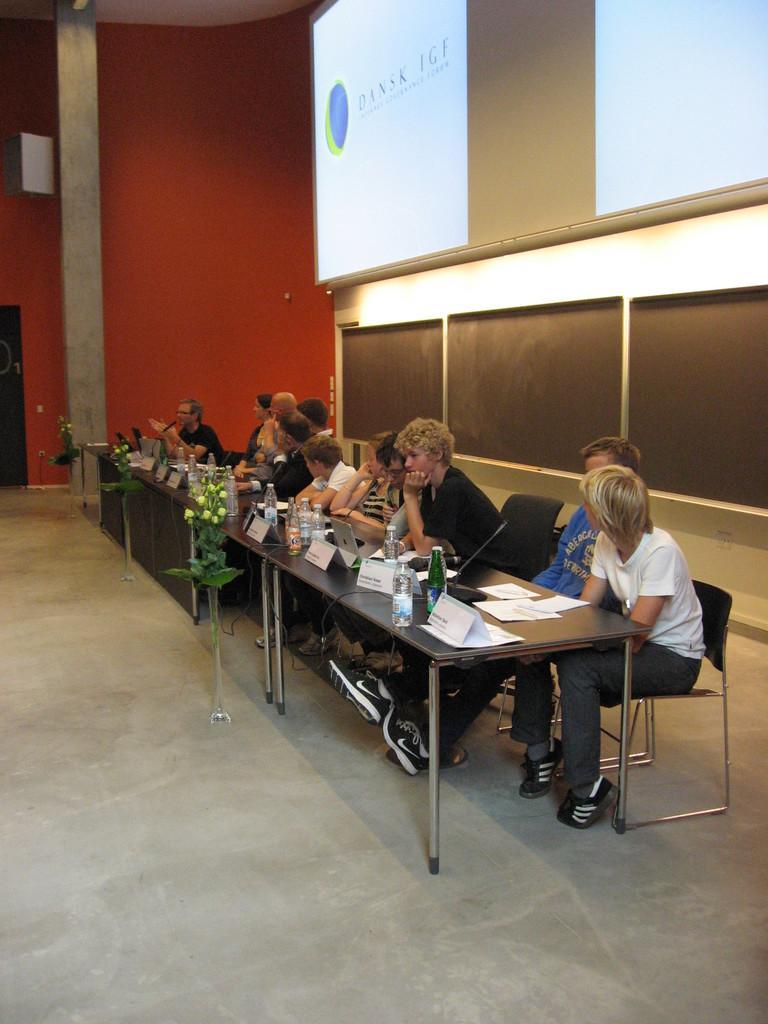Could you give a brief overview of what you see in this image? There are some persons sitting on the chairs as we can see in the middle of this image. There are some tables present in the middle of this image. There are some objects kept on it. There is a wall in the background. There is a screen as we can see at the top right side of this image. 